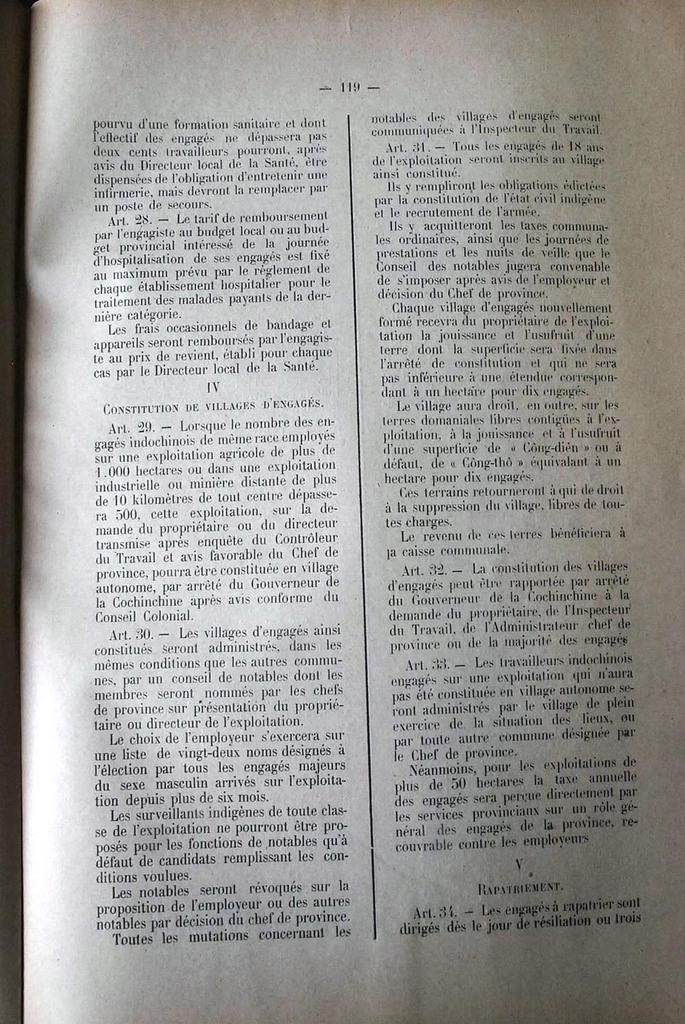What is the page number of the text?
Make the answer very short. 119. Is the text in english?
Your answer should be very brief. No. 